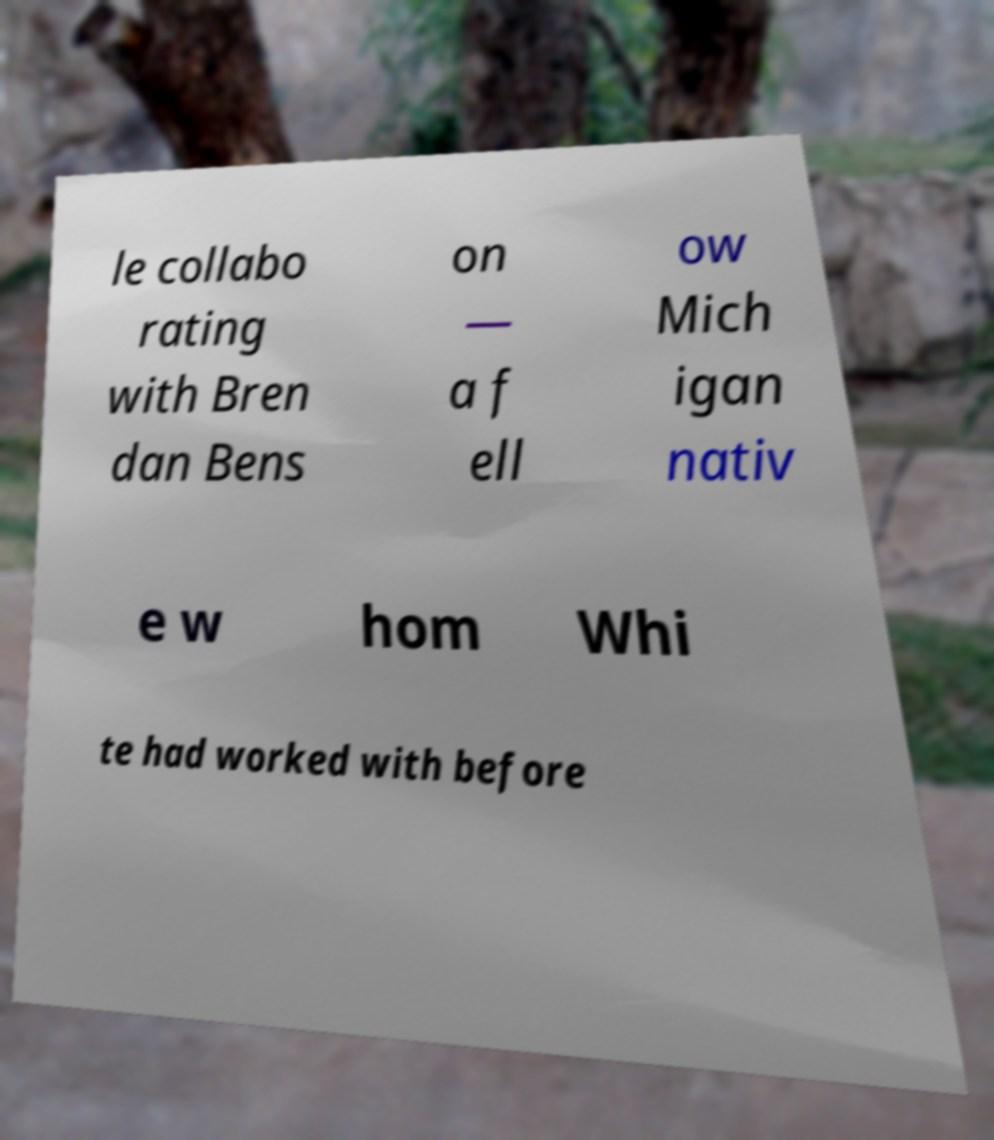Can you accurately transcribe the text from the provided image for me? le collabo rating with Bren dan Bens on — a f ell ow Mich igan nativ e w hom Whi te had worked with before 